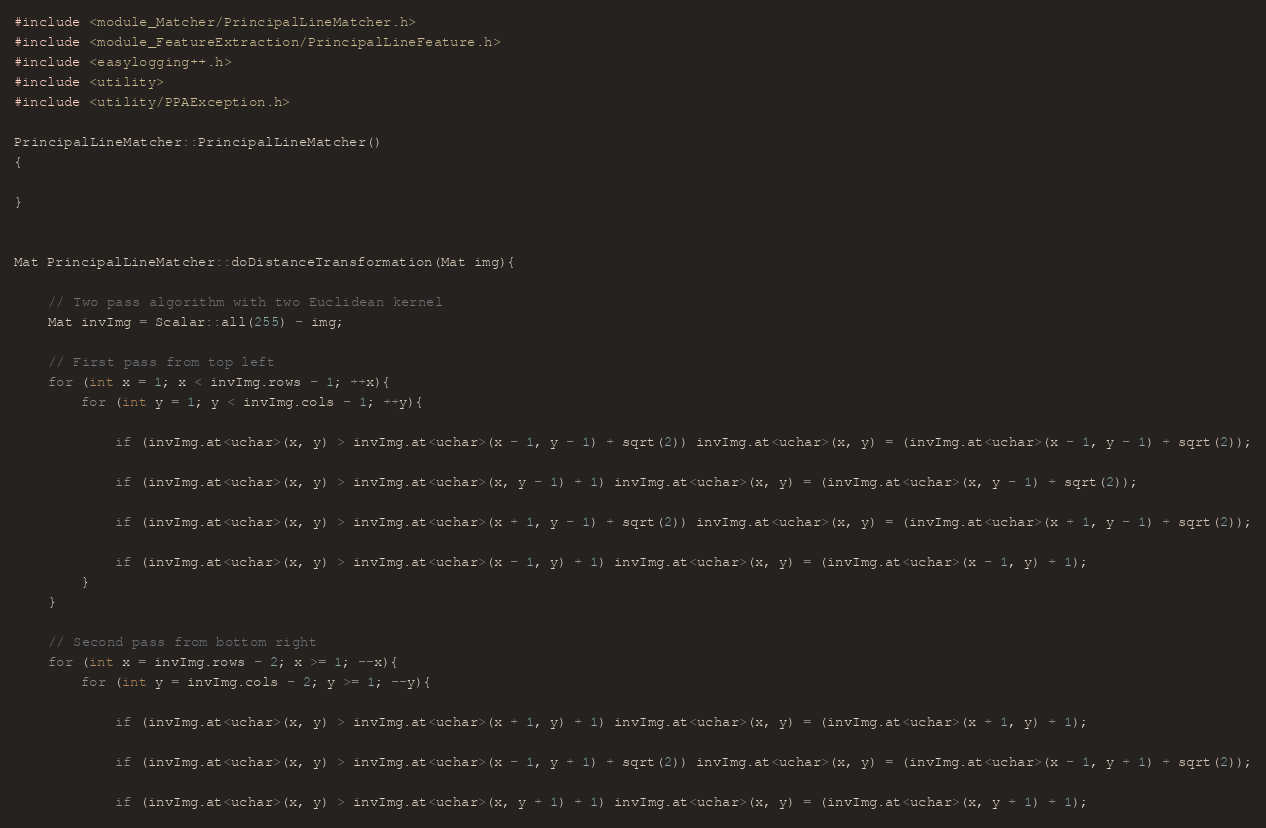<code> <loc_0><loc_0><loc_500><loc_500><_C++_>#include <module_Matcher/PrincipalLineMatcher.h>
#include <module_FeatureExtraction/PrincipalLineFeature.h>
#include <easylogging++.h>
#include <utility>
#include <utility/PPAException.h>

PrincipalLineMatcher::PrincipalLineMatcher()
{

}


Mat PrincipalLineMatcher::doDistanceTransformation(Mat img){

    // Two pass algorithm with two Euclidean kernel
	Mat invImg = Scalar::all(255) - img;

    // First pass from top left
	for (int x = 1; x < invImg.rows - 1; ++x){
		for (int y = 1; y < invImg.cols - 1; ++y){

            if (invImg.at<uchar>(x, y) > invImg.at<uchar>(x - 1, y - 1) + sqrt(2)) invImg.at<uchar>(x, y) = (invImg.at<uchar>(x - 1, y - 1) + sqrt(2));

            if (invImg.at<uchar>(x, y) > invImg.at<uchar>(x, y - 1) + 1) invImg.at<uchar>(x, y) = (invImg.at<uchar>(x, y - 1) + sqrt(2));

            if (invImg.at<uchar>(x, y) > invImg.at<uchar>(x + 1, y - 1) + sqrt(2)) invImg.at<uchar>(x, y) = (invImg.at<uchar>(x + 1, y - 1) + sqrt(2));

            if (invImg.at<uchar>(x, y) > invImg.at<uchar>(x - 1, y) + 1) invImg.at<uchar>(x, y) = (invImg.at<uchar>(x - 1, y) + 1);
		}
	}

    // Second pass from bottom right
	for (int x = invImg.rows - 2; x >= 1; --x){
		for (int y = invImg.cols - 2; y >= 1; --y){

            if (invImg.at<uchar>(x, y) > invImg.at<uchar>(x + 1, y) + 1) invImg.at<uchar>(x, y) = (invImg.at<uchar>(x + 1, y) + 1);

            if (invImg.at<uchar>(x, y) > invImg.at<uchar>(x - 1, y + 1) + sqrt(2)) invImg.at<uchar>(x, y) = (invImg.at<uchar>(x - 1, y + 1) + sqrt(2));

            if (invImg.at<uchar>(x, y) > invImg.at<uchar>(x, y + 1) + 1) invImg.at<uchar>(x, y) = (invImg.at<uchar>(x, y + 1) + 1);
</code> 